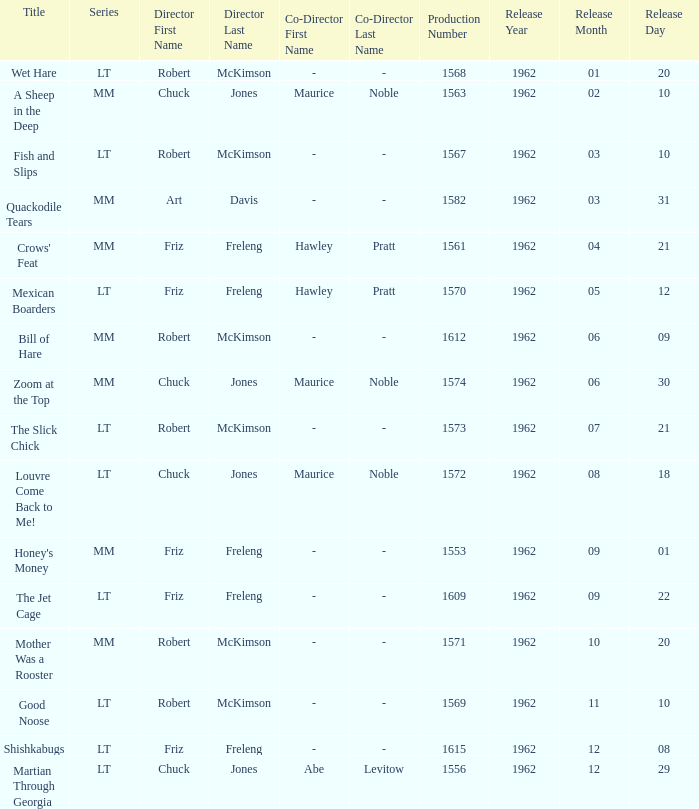What is the title of the film with production number 1553, directed by Friz Freleng? Honey's Money. 